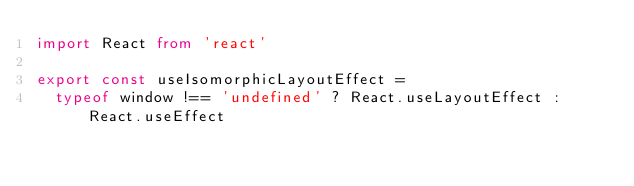Convert code to text. <code><loc_0><loc_0><loc_500><loc_500><_TypeScript_>import React from 'react'

export const useIsomorphicLayoutEffect =
  typeof window !== 'undefined' ? React.useLayoutEffect : React.useEffect
</code> 